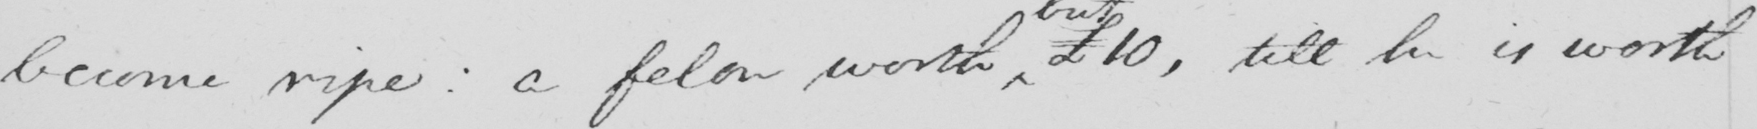Transcribe the text shown in this historical manuscript line. become ripe :  a felon worth £10 , till he is worth 